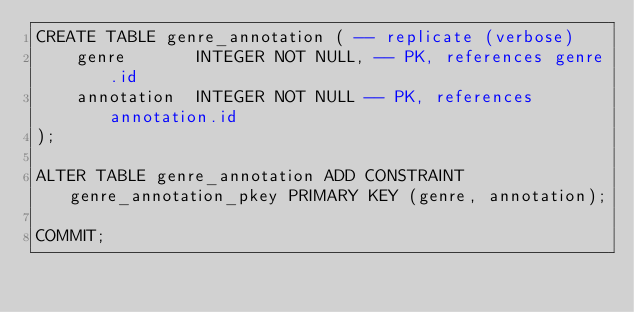<code> <loc_0><loc_0><loc_500><loc_500><_SQL_>CREATE TABLE genre_annotation ( -- replicate (verbose)
    genre       INTEGER NOT NULL, -- PK, references genre.id
    annotation  INTEGER NOT NULL -- PK, references annotation.id
);

ALTER TABLE genre_annotation ADD CONSTRAINT genre_annotation_pkey PRIMARY KEY (genre, annotation);

COMMIT;
</code> 